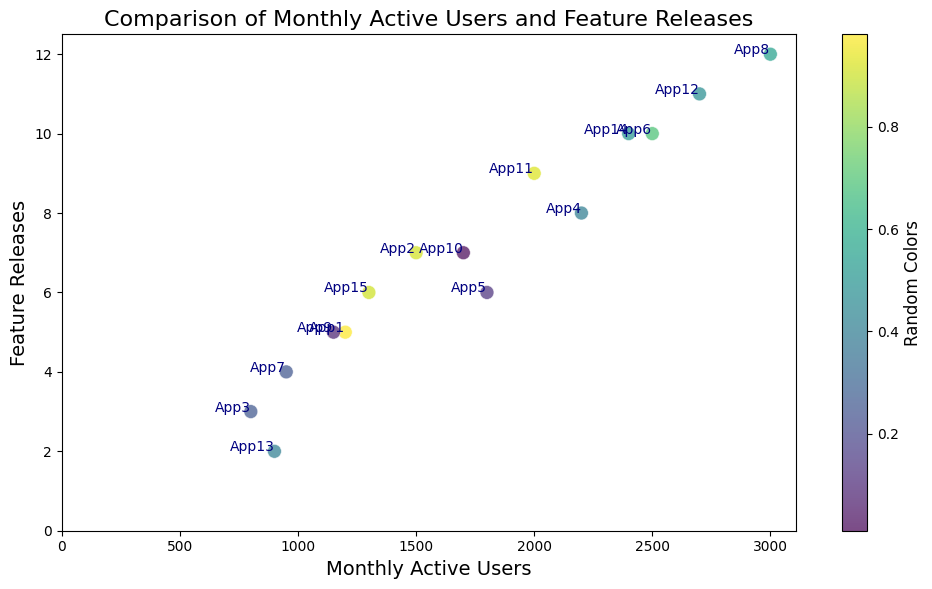What's the application with the highest number of monthly active users? By observation, the highest y-axis value represents the monthly active users. The application 'App8' has the highest y-value, which is 3000.
Answer: App8 How many applications have at least 2000 monthly active users? By counting the instances on the x-axis where the values are 2000 and above: App4, App6, App8, App11, App12, App14. There are 6 applications.
Answer: 6 Which application released the least number of features? Look for the lowest value on the y-axis. The application 'App13' has the lowest y-value with 2 feature releases.
Answer: App13 What is the average number of feature releases for applications with more than 1500 monthly active users? The applications with more than 1500 monthly active users are: App2, App4, App5, App6, App8, App10, App11, App12, App14. The number of feature releases for these applications are 7, 8, 6, 10, 12, 7, 9, 11, and 10. The average is calculated as (7+8+6+10+12+7+9+11+10) / 9 = 9
Answer: 9 Which application is an outlier in terms of feature releases with relatively low monthly active users? By observation, look for an application with a high number of feature releases but lower monthly active users. 'App13' only has 2 feature releases and 900 monthly active users, which is considered low in both terms.
Answer: App13 What is the median number of monthly active users across all applications? Order the monthly active users and find the middle value in the list: [800, 900, 950, 1150, 1200, 1300, 1500, 1700, 1800, 2000, 2200, 2400, 2500, 2700, 3000]. The median value is the 8th value, which is 1700.
Answer: 1700 How many applications released more than 8 features? Count instances on the y-axis where values are higher than 8: App6, App8, App11, App12, App14. There are 5 applications.
Answer: 5 Which two applications have the closest number of monthly active users? By looking closely at the plot, 'App1' and 'App9' are very close in terms of monthly active users with values 1200 and 1150 respectively.
Answer: App1 and App9 Is there any correlation between monthly active users and the number of feature releases? Generally, as the number of feature releases increases, monthly active users also seem to increase, suggesting a positive correlation.
Answer: Positive correlation 